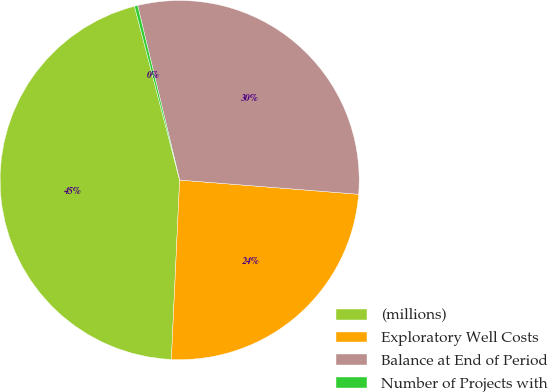Convert chart to OTSL. <chart><loc_0><loc_0><loc_500><loc_500><pie_chart><fcel>(millions)<fcel>Exploratory Well Costs<fcel>Balance at End of Period<fcel>Number of Projects with<nl><fcel>45.22%<fcel>24.47%<fcel>30.02%<fcel>0.29%<nl></chart> 